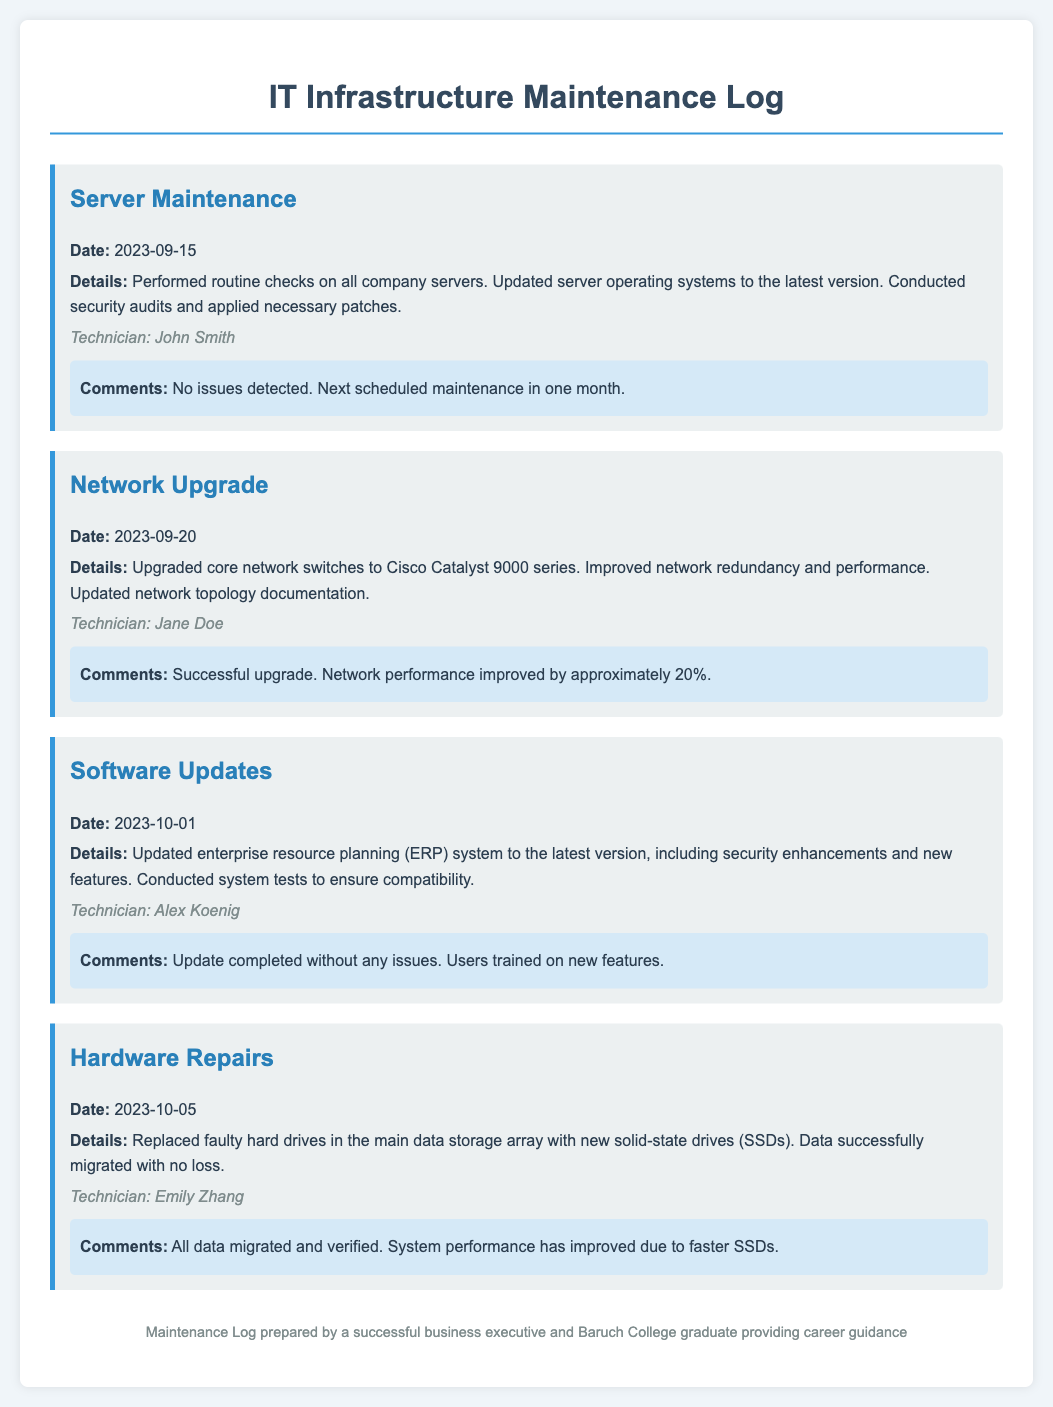What is the date of the server maintenance? The server maintenance was performed on September 15, 2023.
Answer: September 15, 2023 Who conducted the network upgrade? The network upgrade was conducted by Jane Doe.
Answer: Jane Doe What type of hardware was replaced on October 5, 2023? Faulty hard drives were replaced with new solid-state drives (SSDs).
Answer: solid-state drives (SSDs) What was the improvement in network performance after the upgrade? The network performance improved by approximately 20%.
Answer: 20% What system was updated on October 1, 2023? The enterprise resource planning (ERP) system was updated.
Answer: ERP system What technician's name is associated with the software updates? The technician associated with the software updates is Alex Koenig.
Answer: Alex Koenig What was the result of the hardware repairs? All data migrated and verified successfully.
Answer: All data migrated and verified What is the next scheduled maintenance after server maintenance? The next scheduled maintenance is in one month.
Answer: in one month What kind of maintenance activity was performed on September 20, 2023? A network upgrade was the maintenance activity performed.
Answer: network upgrade 